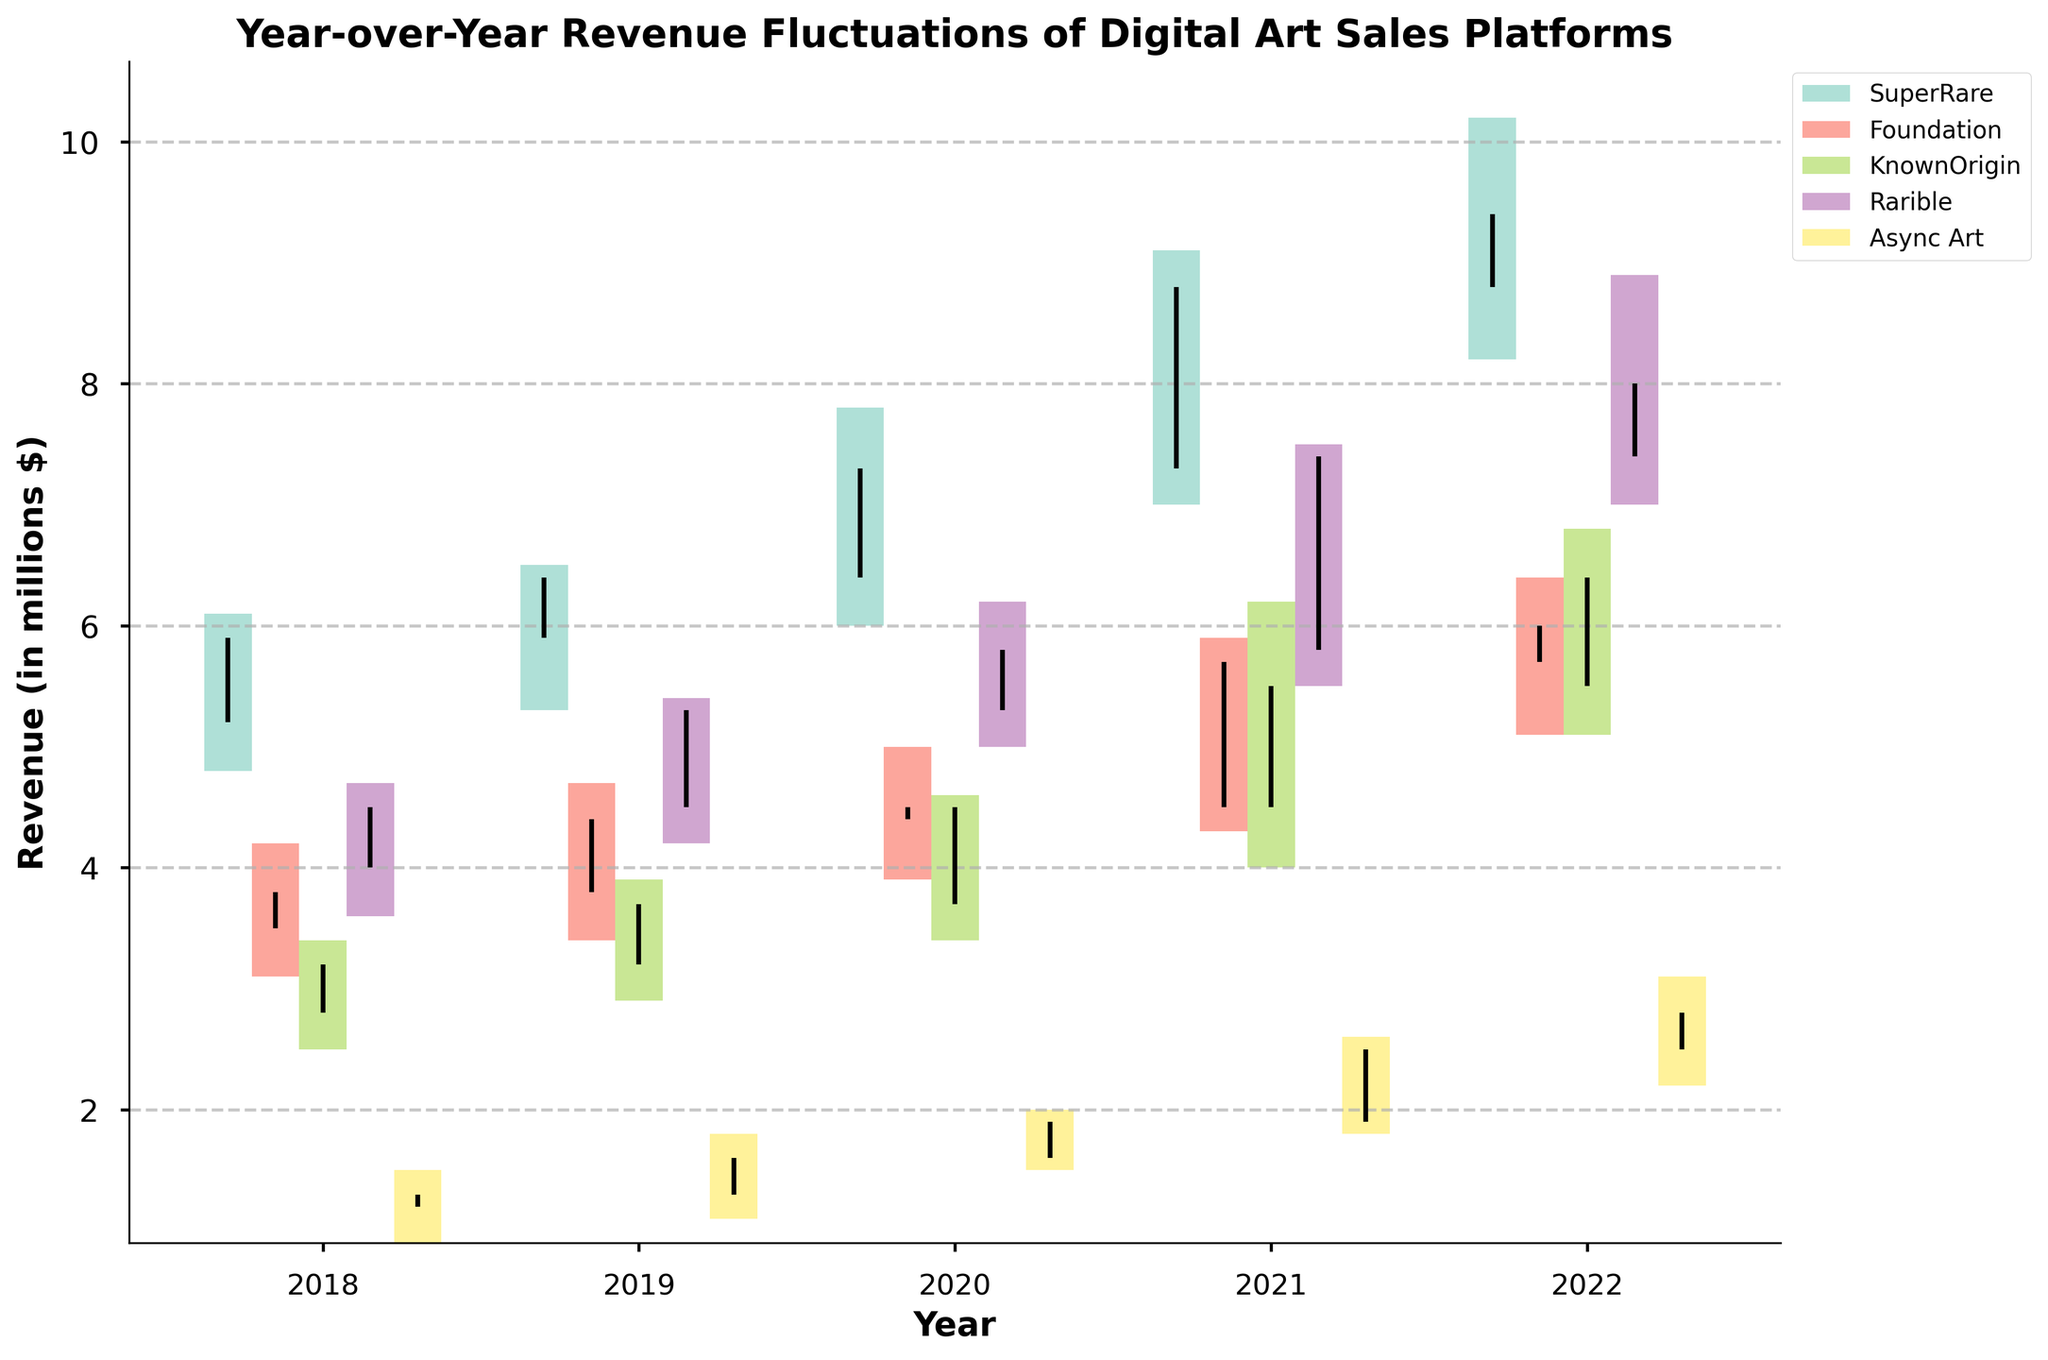What's the title of the figure? The title of the figure is typically located at the top of the plot. In this case, the title is "Year-over-Year Revenue Fluctuations of Digital Art Sales Platforms".
Answer: Year-over-Year Revenue Fluctuations of Digital Art Sales Platforms How many platforms are represented in the figure? The platforms can be identified by the legend on the right side of the plot. There are labels for each platform in the figure.
Answer: 5 Which platform had the highest revenue close value in 2022? To find this, look for the highest closing value among all platforms for the year 2022. The closing value is indicated by the end point of the vertical line for each bar. In 2022, the highest close value is for SuperRare with a closing value of 9.4.
Answer: SuperRare What was the lowest revenue close value for Foundation across all years? To determine this, inspect all the closing values for Foundation across all years. The lowest closing value for Foundation is in 2018, with a closing value of 3.8.
Answer: 3.8 Which year did Rarible experience the largest range in revenue? The range can be calculated by subtracting the lowest revenue from the highest revenue for each year. For Rarible, the largest range occurs in the year with the widest bar. The largest range for Rarible is in 2021 with a range from 5.5 to 7.5, resulting in a range of 2.0.
Answer: 2021 How did the revenue of KnownOrigin change from the opening in 2021 to the closing in 2022? Calculate the change by subtracting the opening value in 2021 from the closing value in 2022. KnownOrigin opened at 4.5 in 2021 and closed at 6.4 in 2022, so the change is 6.4 - 4.5 = 1.9.
Answer: 1.9 Which platform showed the most consistent revenue growth across the years shown? To identify consistent growth, compare the closing values of each platform across the years. For SuperRare, each year's close is higher than the previous year's close, indicating consistent growth from 2018 to 2022.
Answer: SuperRare What's the average high revenue of Async Art from 2018 to 2022? To find the average, sum the high values for Async Art over the years and divide by the number of years. The high values are 1.5, 1.8, 2.0, 2.6, and 3.1. The sum is 1.5 + 1.8 + 2.0 + 2.6 + 3.1 = 11.0. Divide by 5 to get the average: 11.0 / 5 = 2.2.
Answer: 2.2 Which year depicted the highest peak revenue high for all platforms combined? Locate the highest peak revenue high among all years and platforms. The highest overall peak is in 2022 by SuperRare, with a high value of 10.2.
Answer: 2022 Did Foundation's revenue close at a higher value in 2019 compared to 2018? Compare the closing value of Foundation in 2019 against 2018. The closing value in 2018 is 3.8, and in 2019 it is 4.4. Since 4.4 is greater than 3.8, Foundation's close was higher in 2019.
Answer: Yes Among the given years, in which year did Async Art see the largest increase in closing values? To determine this, calculate the increase in closing values for each consecutive year and find the largest one. The largest increase for Async Art is from 2020 (1.9) to 2021 (2.5), which is an increase of 0.6.
Answer: 2021 